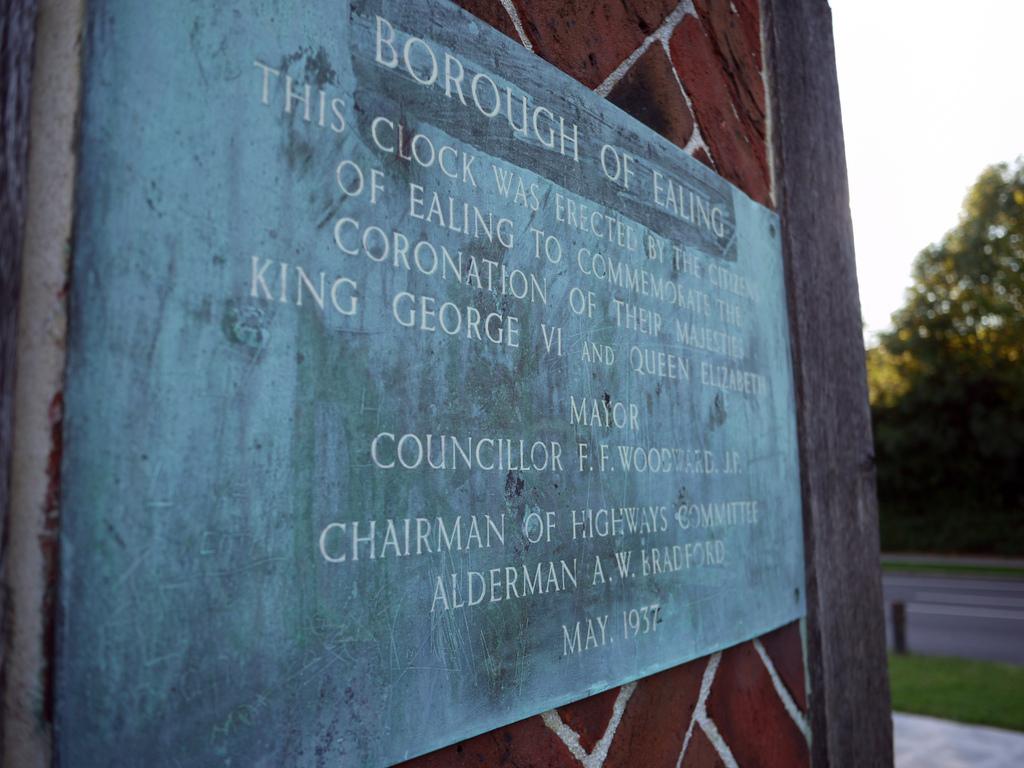What reason does this memorial give for the clock being erected?
Provide a short and direct response. To commemorate the coronation of their majesties king george vi and queen elizabeth. When was the borough founded?
Provide a succinct answer. May 1937. 